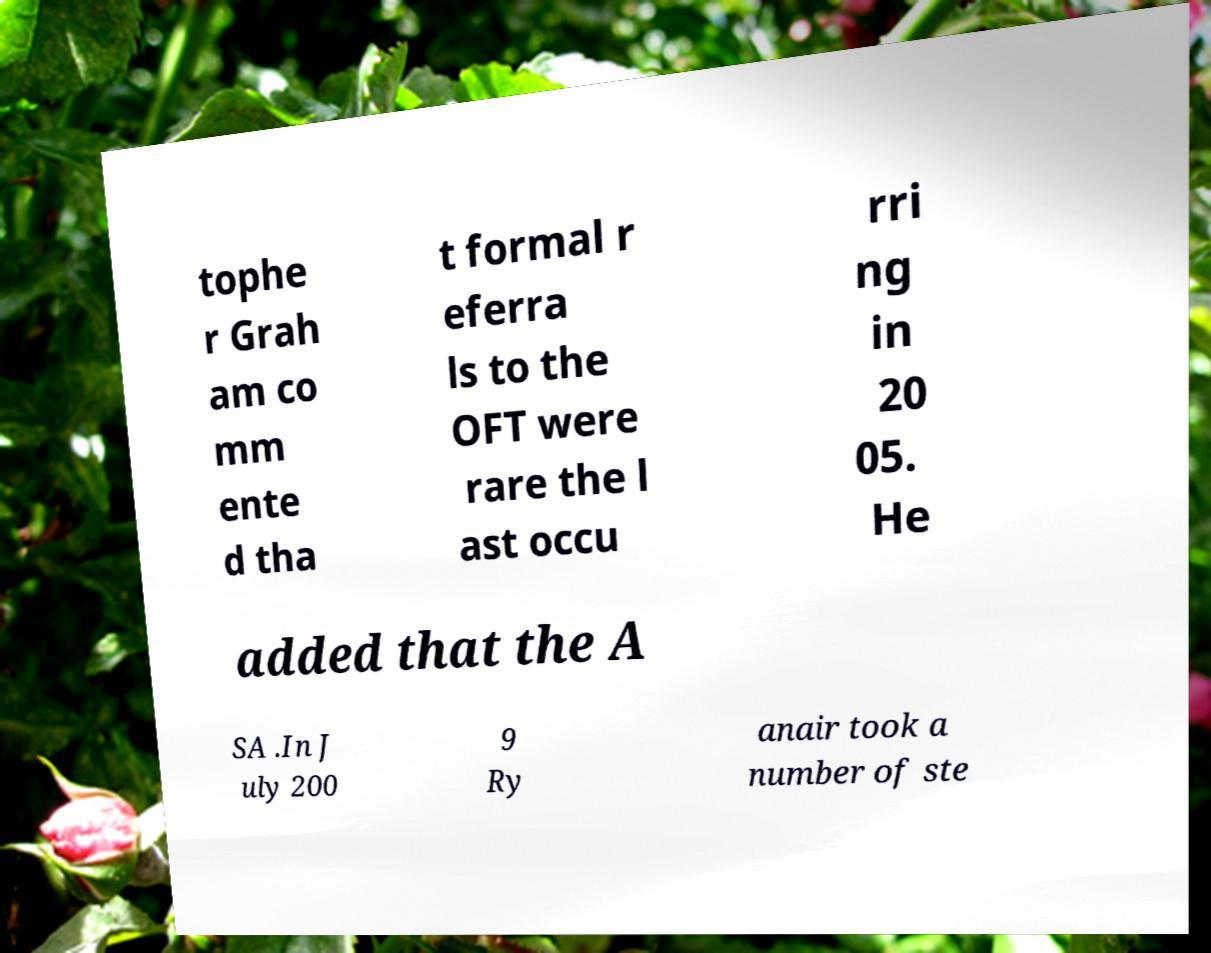For documentation purposes, I need the text within this image transcribed. Could you provide that? tophe r Grah am co mm ente d tha t formal r eferra ls to the OFT were rare the l ast occu rri ng in 20 05. He added that the A SA .In J uly 200 9 Ry anair took a number of ste 